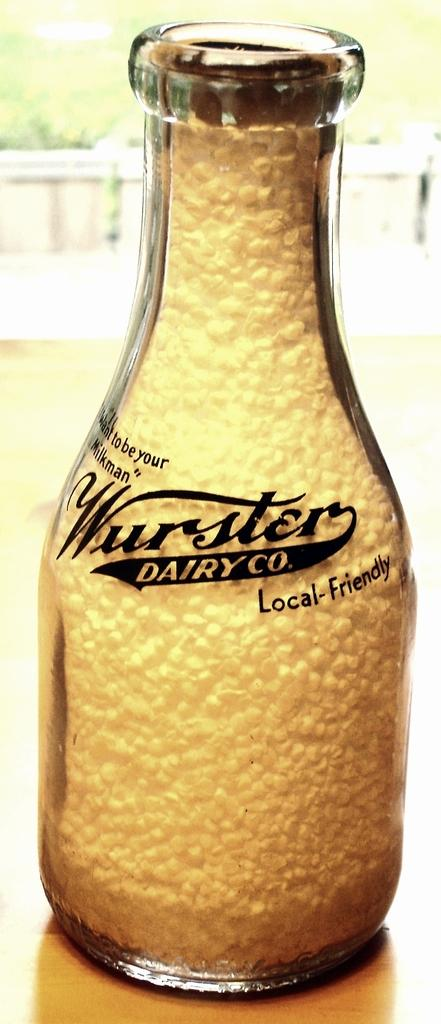What is in the bottle that is visible in the image? There is a bottle of juice in the image. What additional information can be found on the bottle? The bottle has the words "Wurster Dairy Co" written on it. What invention is being demonstrated by the geese in the image? There are no geese present in the image, and therefore no invention can be demonstrated by them. 